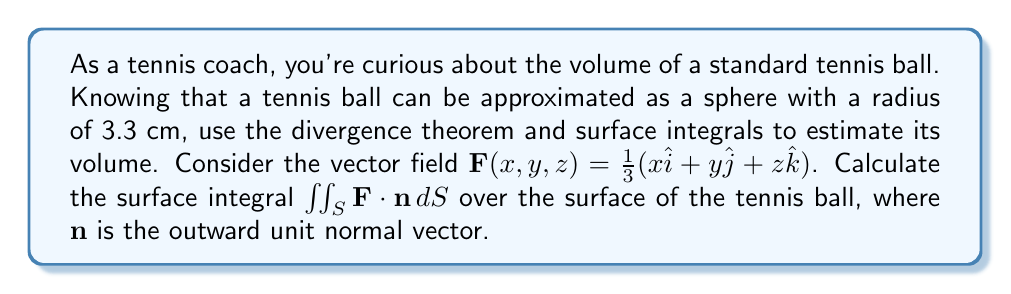Help me with this question. To solve this problem, we'll use the divergence theorem and surface integrals. Here's a step-by-step explanation:

1) The divergence theorem states that:

   $$\iiint_V \nabla \cdot \mathbf{F} \, dV = \iint_S \mathbf{F} \cdot \mathbf{n} \, dS$$

   where $V$ is the volume enclosed by the surface $S$.

2) First, let's calculate the divergence of $\mathbf{F}$:

   $$\nabla \cdot \mathbf{F} = \frac{\partial}{\partial x}(\frac{1}{3}x) + \frac{\partial}{\partial y}(\frac{1}{3}y) + \frac{\partial}{\partial z}(\frac{1}{3}z) = \frac{1}{3} + \frac{1}{3} + \frac{1}{3} = 1$$

3) Now, the left side of the divergence theorem becomes:

   $$\iiint_V \nabla \cdot \mathbf{F} \, dV = \iiint_V 1 \, dV = V$$

   where $V$ is the volume of the tennis ball.

4) For the right side, we need to calculate $\iint_S \mathbf{F} \cdot \mathbf{n} \, dS$. 
   For a sphere of radius $r$, the outward unit normal vector is $\mathbf{n} = \frac{1}{r}(x\hat{i} + y\hat{j} + z\hat{k})$.

5) Therefore:

   $$\mathbf{F} \cdot \mathbf{n} = \frac{1}{3}(x\hat{i} + y\hat{j} + z\hat{k}) \cdot \frac{1}{r}(x\hat{i} + y\hat{j} + z\hat{k}) = \frac{1}{3r}(x^2 + y^2 + z^2) = \frac{r}{3}$$

   since $x^2 + y^2 + z^2 = r^2$ on the surface of a sphere.

6) The surface area of a sphere is $4\pi r^2$, so:

   $$\iint_S \mathbf{F} \cdot \mathbf{n} \, dS = \iint_S \frac{r}{3} \, dS = \frac{r}{3} \cdot 4\pi r^2 = \frac{4\pi r^3}{3}$$

7) By the divergence theorem, this equals the volume of the tennis ball:

   $$V = \frac{4\pi r^3}{3}$$

8) Substituting $r = 3.3$ cm:

   $$V = \frac{4\pi (3.3\,\text{cm})^3}{3} \approx 150.53\,\text{cm}^3$$

Thus, we've estimated the volume of the tennis ball using surface integrals.
Answer: The volume of the tennis ball is approximately $150.53\,\text{cm}^3$. 